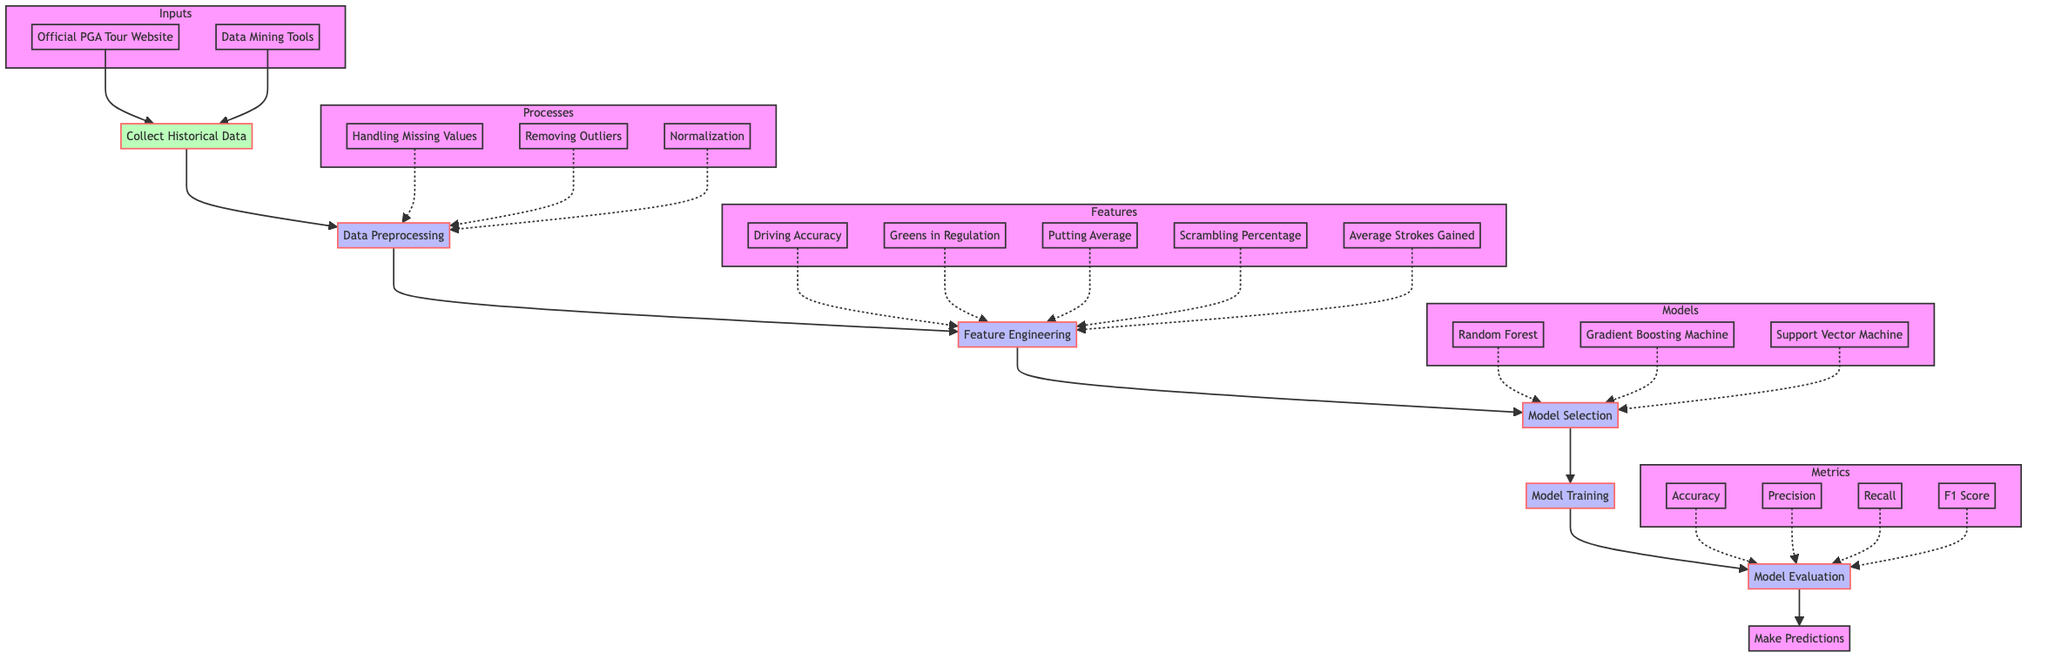What is the first step in the flowchart? The first step in the flowchart is "Collect Historical Data," which is the starting point in the process of analyzing PGA Tour statistics.
Answer: Collect Historical Data How many processes are defined in the diagram? The diagram shows six processes: Data Preprocessing, Feature Engineering, Model Selection, Model Training, Model Evaluation, and Make Predictions.
Answer: Six What is the output of the Model Evaluation step? The output after the Model Evaluation step is "Model Performance Metrics," which includes various evaluation metrics.
Answer: Model Performance Metrics Which models are available for selection in the Model Selection step? The available models to choose from in the Model Selection step are Random Forest, Gradient Boosting Machine, and Support Vector Machine.
Answer: Random Forest, Gradient Boosting Machine, Support Vector Machine What is the relationship between Data Preprocessing and Feature Engineering? Data Preprocessing outputs Processed Data, which is then used as input for Feature Engineering, indicating a direct flow from one step to the next.
Answer: Direct flow from Preprocessing to Feature Engineering What specific metrics are used to evaluate model performance? The metrics used for model performance evaluation are Accuracy, Precision, Recall, and F1 Score.
Answer: Accuracy, Precision, Recall, F1 Score Which input sources are utilized to collect historical data? The input sources for collecting historical data include the Official PGA Tour Website and Data Mining Tools.
Answer: Official PGA Tour Website, Data Mining Tools What is the output of the Make Predictions step? The output from the Make Predictions step is "Predicted Winners," as the final goal of the analysis is to predict tournament outcomes.
Answer: Predicted Winners What preprocessing techniques are involved in the Data Preprocessing step? The three preprocessing techniques involved are Handling Missing Values, Removing Outliers, and Normalization.
Answer: Handling Missing Values, Removing Outliers, Normalization What is the last process in the flowchart? The last process in the flowchart is "Make Predictions," which is the final step of the entire analysis procedure.
Answer: Make Predictions 